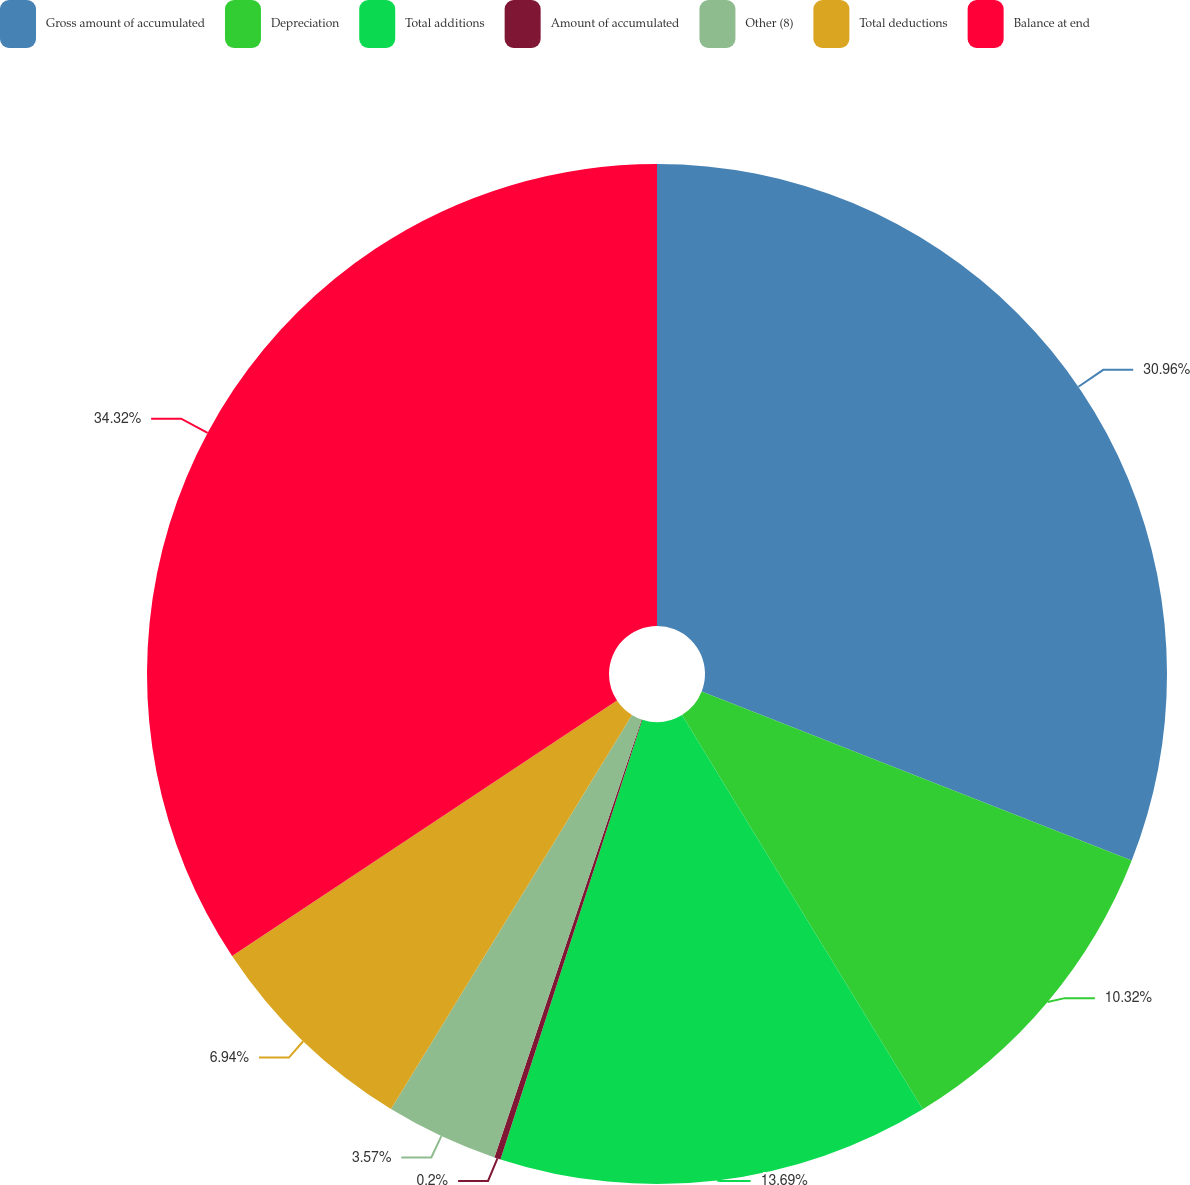Convert chart. <chart><loc_0><loc_0><loc_500><loc_500><pie_chart><fcel>Gross amount of accumulated<fcel>Depreciation<fcel>Total additions<fcel>Amount of accumulated<fcel>Other (8)<fcel>Total deductions<fcel>Balance at end<nl><fcel>30.96%<fcel>10.32%<fcel>13.69%<fcel>0.2%<fcel>3.57%<fcel>6.94%<fcel>34.33%<nl></chart> 